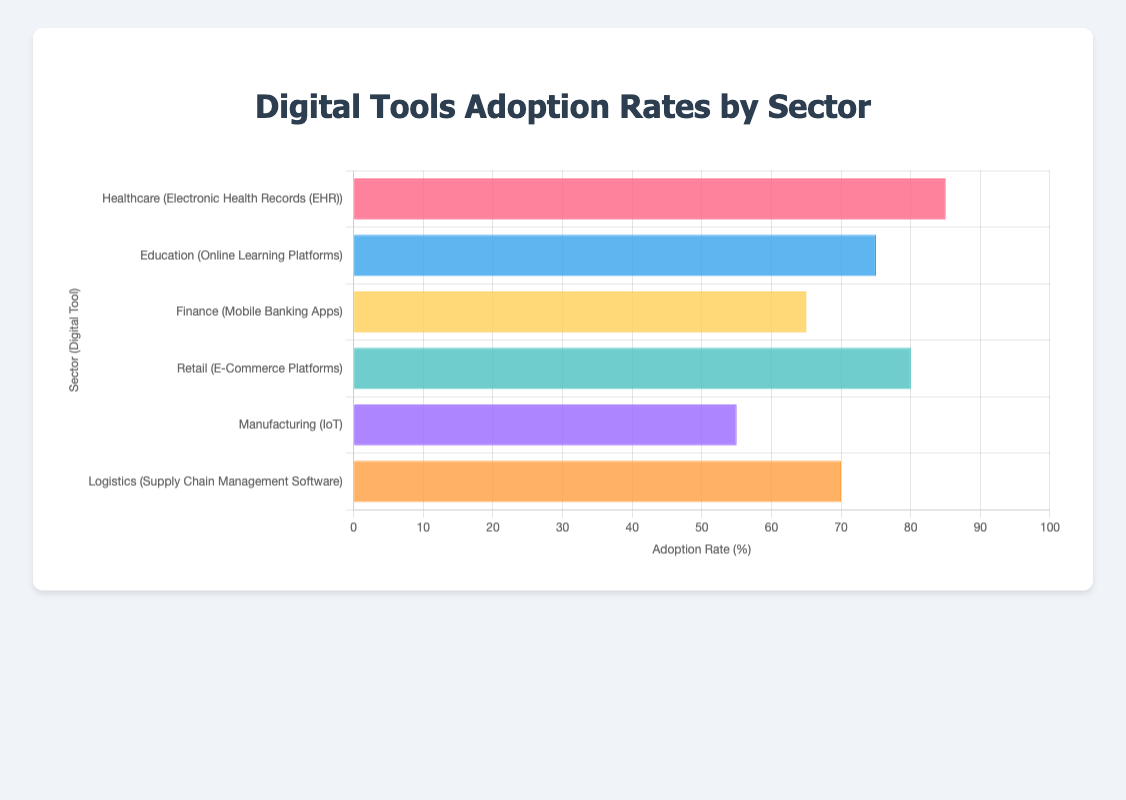Which sector has the highest adoption rate and what is it? By looking at the figure, we can see that the Healthcare sector has the tallest bar, indicating it has the highest adoption rate at 85%.
Answer: Healthcare, 85% Which age group contributes most to the adoption of Online Learning Platforms in Education and what is their percentage? For the Education sector, examining the user demographics reveals the age group 18-29 has the highest percentage at 50%.
Answer: 18-29, 50% Which digital tool has a higher adoption rate: Mobile Banking Apps in Finance or E-Commerce Platforms in Retail? By comparing the bars for Finance and Retail, we find that E-Commerce Platforms in Retail have an adoption rate of 80%, higher than Mobile Banking Apps in Finance at 65%.
Answer: E-Commerce Platforms What is the average adoption rate across all sectors? Summing the adoption rates for Healthcare (85), Education (75), Finance (65), Retail (80), Manufacturing (55), and Logistics (70) gives 430. Dividing by the 6 sectors, we get an average adoption rate of 430/6 ≈ 71.7.
Answer: 71.7 In which sector does the age group 30-49 contribute the most to the digital tool adoption? By comparing the percentage values for the age group 30-49 across all sectors, we see the highest contribution is in Manufacturing at 45%.
Answer: Manufacturing Which sector has the smallest percentage of users in the age group 65+ and what is that percentage? By examining the user demographics for each sector, the smallest percentage for the age group 65+ is in Education, where it is 5%.
Answer: Education, 5% How much greater is the adoption rate of Supply Chain Management Software in Logistics compared to IoT in Manufacturing? The adoption rate for Supply Chain Management Software in Logistics is 70%, while for IoT in Manufacturing, it is 55%. The difference is 70% - 55% = 15%.
Answer: 15% What is the combined percentage of users aged 18-29 and 50-64 for Mobile Banking Apps in Finance? Summing the percentage of users aged 18-29 (40%) and 50-64 (20%) for Mobile Banking Apps in Finance gives us a combined percentage of 40% + 20% = 60%.
Answer: 60% Which sector has a more evenly distributed adoption rate among the age groups for its digital tool, and how can you tell? By looking at the user demographics, the Logistics sector with Supply Chain Management Software has percentages of 10%, 45%, 35%, and 10%, showing no extreme values and relatively even distribution among groups.
Answer: Logistics Compare the user demographic distribution for EHR in Healthcare and IoT in Manufacturing. Which has a higher participation from the age group 65+ and what are their respective percentages? The age group 65+ has a participation of 20% in Healthcare for EHR, while in Manufacturing for IoT, it is 10%. Therefore, Healthcare has a higher participation from the 65+ age group.
Answer: Healthcare, 20% 